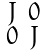<formula> <loc_0><loc_0><loc_500><loc_500>\begin{smallmatrix} J & 0 \\ 0 & J \end{smallmatrix}</formula> 